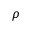Convert formula to latex. <formula><loc_0><loc_0><loc_500><loc_500>\rho</formula> 